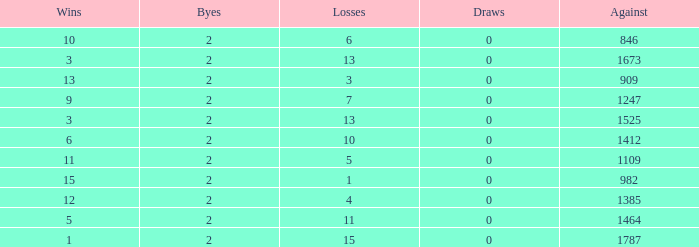What is the average number of Byes when there were less than 0 losses and were against 1247? None. 